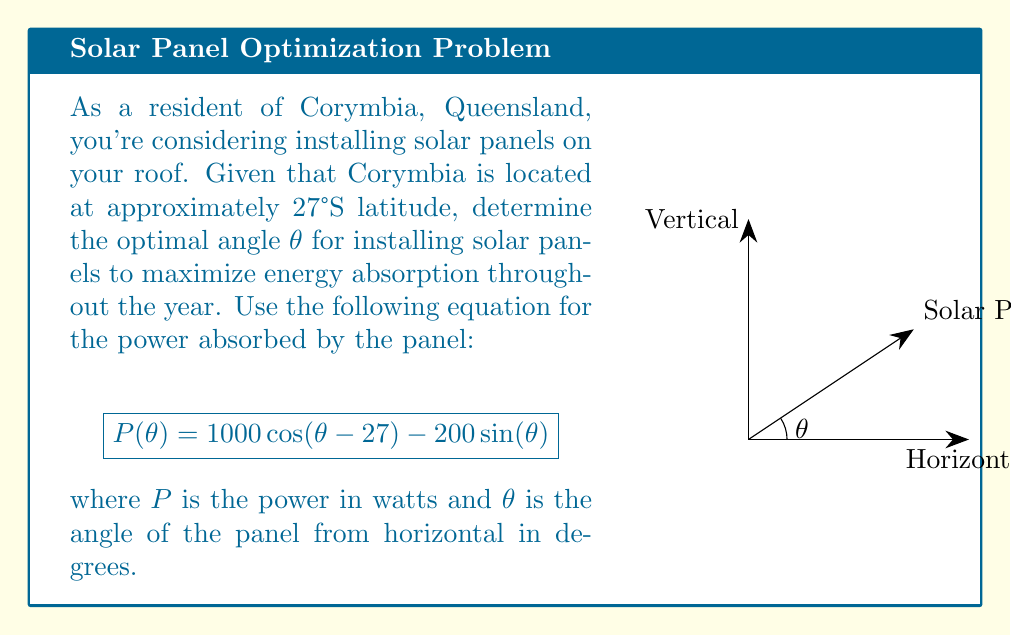Solve this math problem. To find the optimal angle, we need to maximize the power function P(θ). This can be done by finding where the derivative of P(θ) equals zero.

Step 1: Calculate the derivative of P(θ) with respect to θ.
$$\frac{dP}{d\theta} = -1000 \sin(\theta - 27°) - 200 \cos(\theta)$$

Step 2: Set the derivative equal to zero and solve for θ.
$$-1000 \sin(\theta - 27°) - 200 \cos(\theta) = 0$$

Step 3: Use trigonometric identities to simplify:
$$-1000 [\sin(\theta)\cos(27°) - \cos(\theta)\sin(27°)] - 200 \cos(\theta) = 0$$

Step 4: Combine like terms:
$$-1000 \sin(\theta)\cos(27°) + 1000 \cos(\theta)\sin(27°) - 200 \cos(\theta) = 0$$
$$-891.0 \sin(\theta) + 672.6 \cos(\theta) = 0$$

Step 5: Divide both sides by cos(θ):
$$-891.0 \tan(\theta) + 672.6 = 0$$

Step 6: Solve for θ:
$$\tan(\theta) = \frac{672.6}{891.0} = 0.7549$$
$$\theta = \arctan(0.7549) \approx 37.0°$$

Step 7: Verify this is a maximum by checking the second derivative is negative at this point.

The optimal angle for the solar panels is approximately 37.0° from the horizontal.
Answer: $37.0°$ 